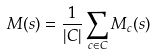Convert formula to latex. <formula><loc_0><loc_0><loc_500><loc_500>M ( s ) = \frac { 1 } { | C | } \sum _ { c \in C } M _ { c } ( s )</formula> 